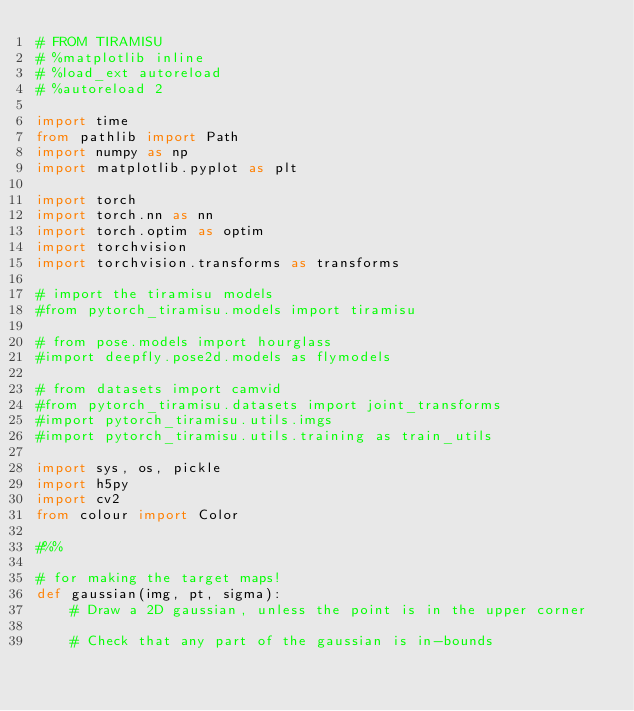Convert code to text. <code><loc_0><loc_0><loc_500><loc_500><_Python_># FROM TIRAMISU
# %matplotlib inline
# %load_ext autoreload
# %autoreload 2

import time
from pathlib import Path
import numpy as np
import matplotlib.pyplot as plt

import torch
import torch.nn as nn
import torch.optim as optim
import torchvision
import torchvision.transforms as transforms

# import the tiramisu models
#from pytorch_tiramisu.models import tiramisu

# from pose.models import hourglass
#import deepfly.pose2d.models as flymodels

# from datasets import camvid
#from pytorch_tiramisu.datasets import joint_transforms
#import pytorch_tiramisu.utils.imgs
#import pytorch_tiramisu.utils.training as train_utils

import sys, os, pickle
import h5py
import cv2
from colour import Color

#%%

# for making the target maps!
def gaussian(img, pt, sigma):
    # Draw a 2D gaussian, unless the point is in the upper corner

    # Check that any part of the gaussian is in-bounds</code> 